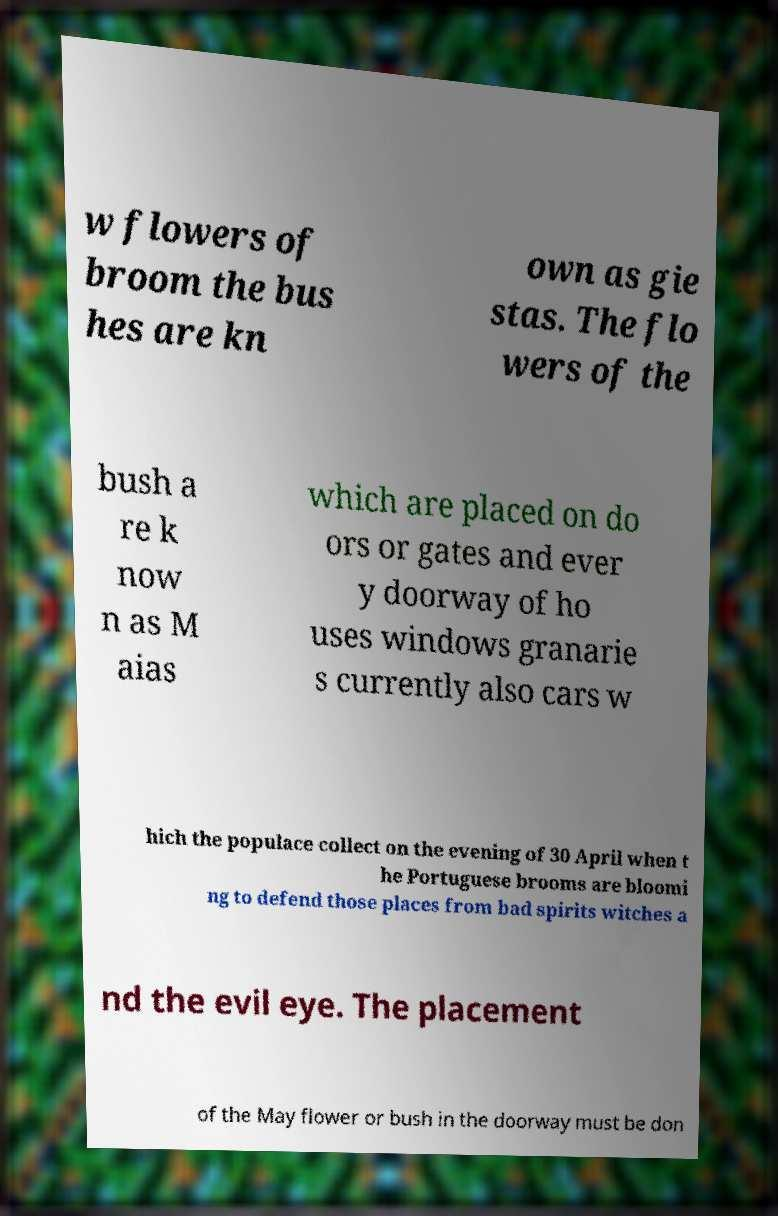There's text embedded in this image that I need extracted. Can you transcribe it verbatim? w flowers of broom the bus hes are kn own as gie stas. The flo wers of the bush a re k now n as M aias which are placed on do ors or gates and ever y doorway of ho uses windows granarie s currently also cars w hich the populace collect on the evening of 30 April when t he Portuguese brooms are bloomi ng to defend those places from bad spirits witches a nd the evil eye. The placement of the May flower or bush in the doorway must be don 